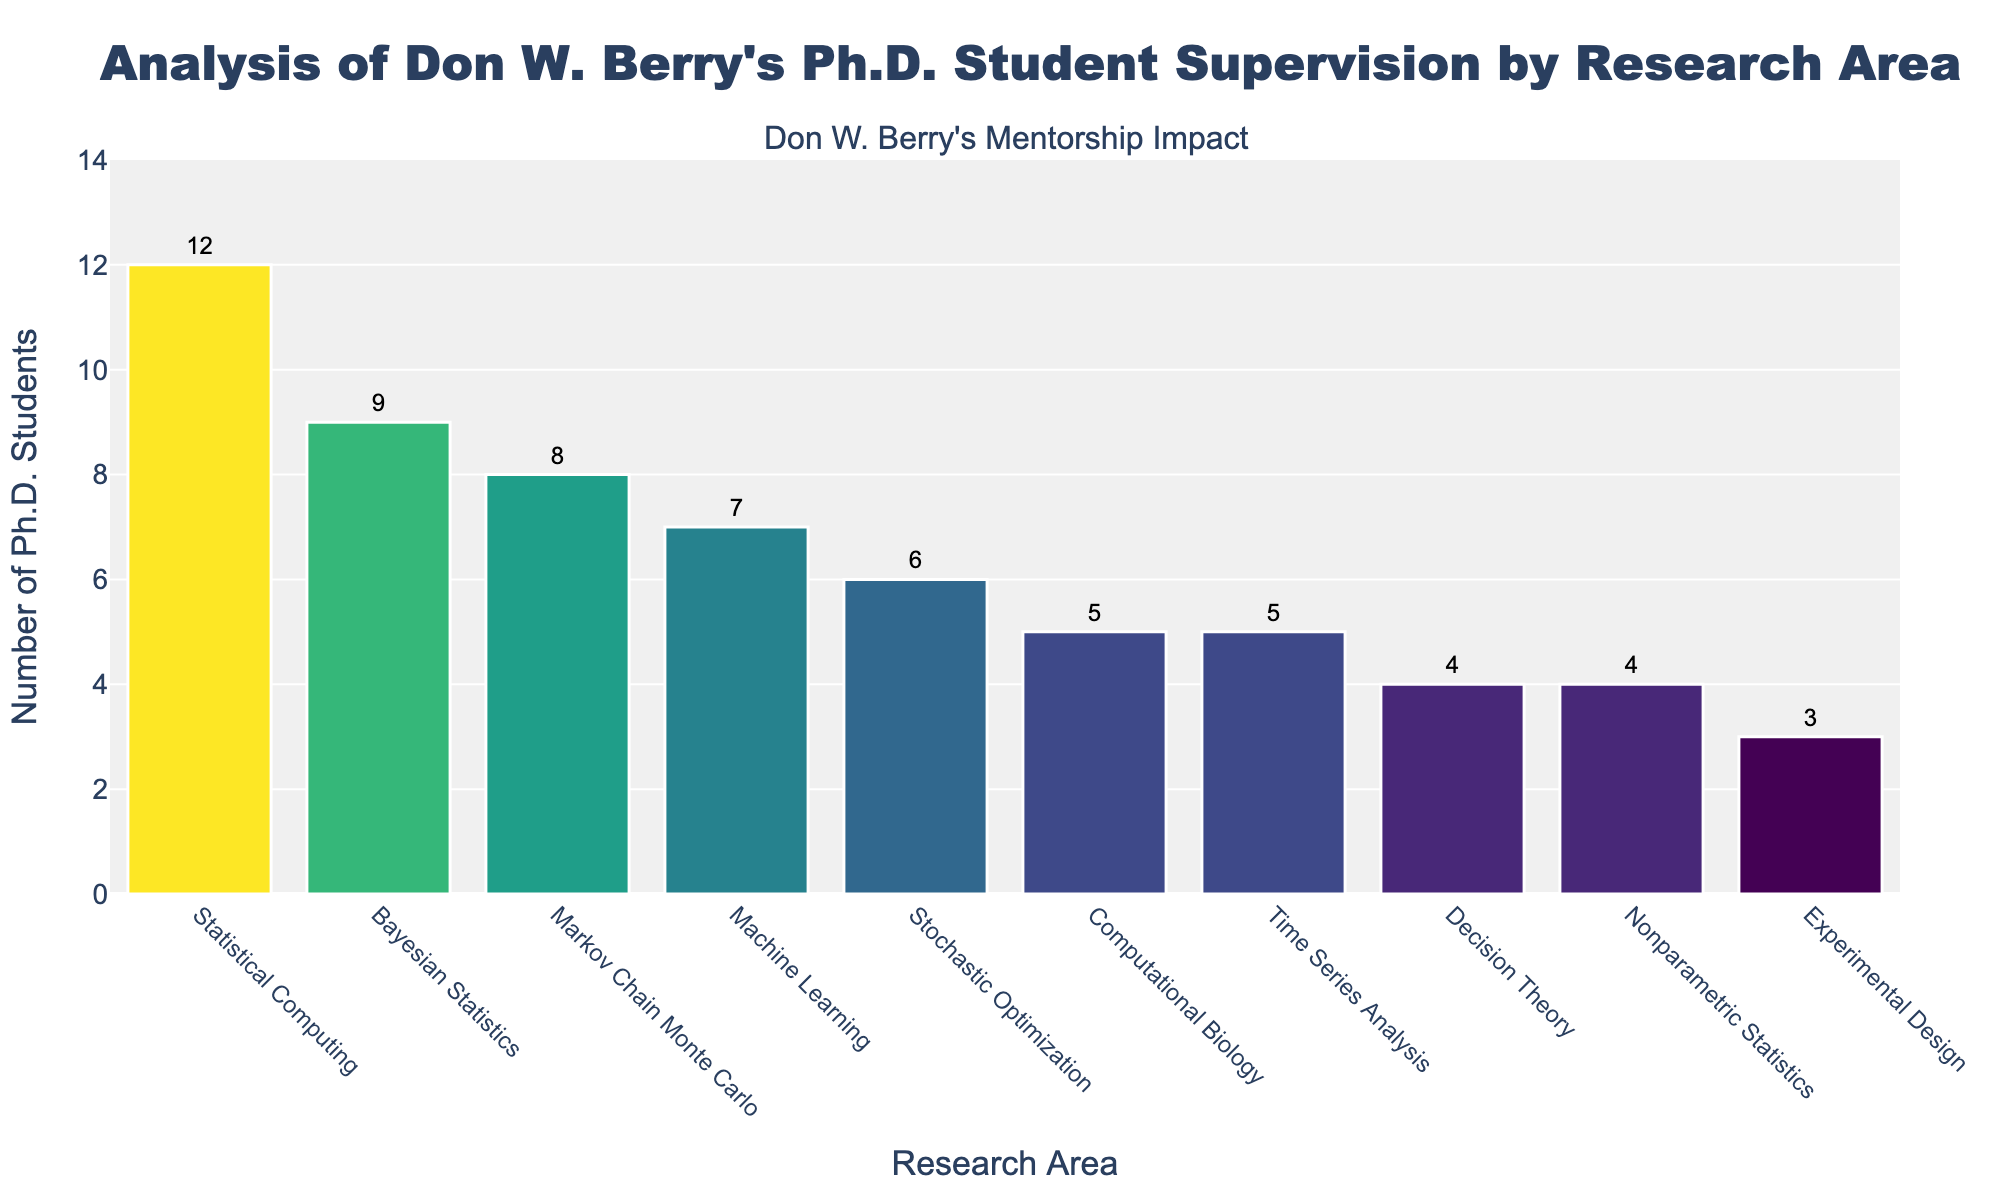Which research area has the highest number of Ph.D. students supervised? The highest bar represents the research area with the most Ph.D. students. The tallest bar corresponds to Statistical Computing.
Answer: Statistical Computing Which research area has the lowest number of Ph.D. students supervised? The shortest bar represents the research area with the lowest number of Ph.D. students. The shortest bar corresponds to Experimental Design.
Answer: Experimental Design What is the total number of Ph.D. students supervised by Don W. Berry in Bayesian Statistics and Machine Learning? Sum the values of Ph.D. students in Bayesian Statistics and Machine Learning. Bayesian Statistics has 9 students, and Machine Learning has 7. 9 + 7 = 16.
Answer: 16 How many more Ph.D. students did Don W. Berry supervise in Statistical Computing than in Decision Theory? Subtract the number of Ph.D. students in Decision Theory from the number in Statistical Computing. Statistical Computing has 12 students, and Decision Theory has 4. 12 - 4 = 8.
Answer: 8 Among Nonparametric Statistics, Computational Biology, and Stochastic Optimization, which area has the second-highest number of Ph.D. students supervised? First, identify the number of Ph.D. students in each area. Nonparametric Statistics has 4, Computational Biology has 5, and Stochastic Optimization has 6. The second-highest is Computational Biology.
Answer: Computational Biology How many areas have more than 5 Ph.D. students supervised? Count the number of bars that extend above the 5-student mark. There are five areas: Statistical Computing, Bayesian Statistics, Machine Learning, Stochastic Optimization, and Markov Chain Monte Carlo.
Answer: 5 What is the total number of Ph.D. students supervised in areas with less than 5 students? Add the number of Ph.D. students in Decision Theory (4), Experimental Design (3), and Nonparametric Statistics (4). 4 + 3 + 4 = 11.
Answer: 11 Which research areas have equal numbers of Ph.D. students supervised? Decision Theory and Nonparametric Statistics each have 4 Ph.D. students, and Time Series Analysis and Computational Biology both have 5 Ph.D. students.
Answer: Decision Theory and Nonparametric Statistics, Time Series Analysis and Computational Biology By how much does the number of Ph.D. students supervised in Markov Chain Monte Carlo surpass the number in Time Series Analysis? Subtract the number of Ph.D. students in Time Series Analysis from the number in Markov Chain Monte Carlo. Markov Chain Monte Carlo has 8 students and Time Series Analysis has 5. 8 - 5 = 3.
Answer: 3 What is the average number of Ph.D. students supervised across all research areas? Sum all the students and divide by the number of research areas. Total students = 12 + 9 + 7 + 5 + 6 + 8 + 4 + 3 + 5 + 4 = 63. There are 10 research areas. 63 / 10 = 6.3.
Answer: 6.3 